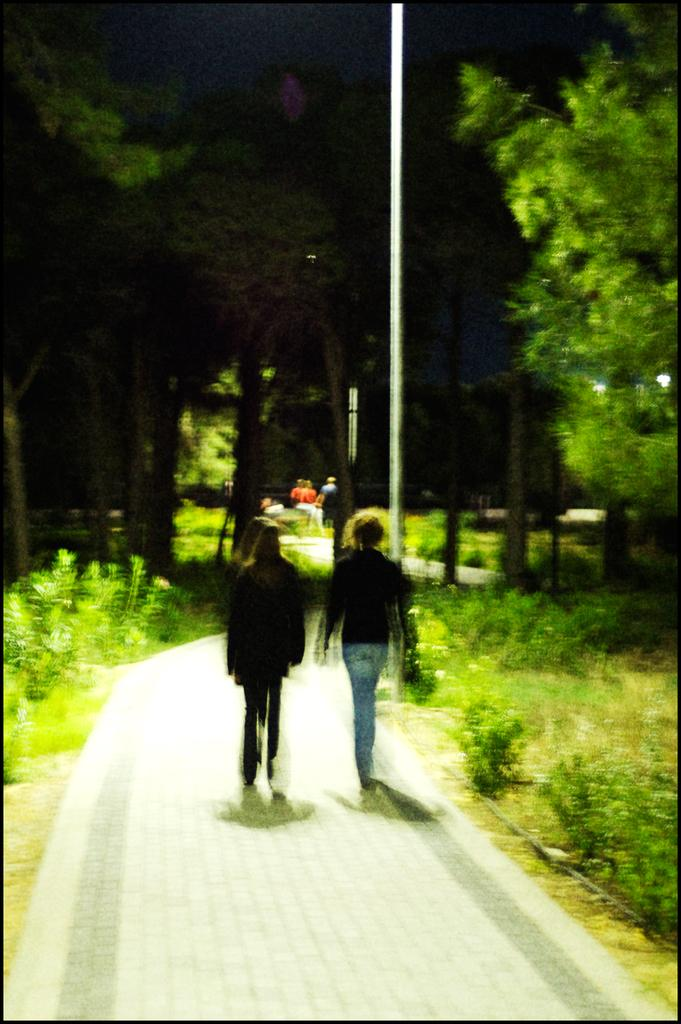What type of vegetation can be seen in the image? There are trees and plants in the image. What structure is present in the image? There is a pole in the image. Who or what is visible in the image? There are people in the image. What are the people doing in the image? The people are walking on a pathway. Can you see the moon in the image? No, the moon is not present in the image. What part of the thumb can be seen in the image? There is no thumb visible in the image. 